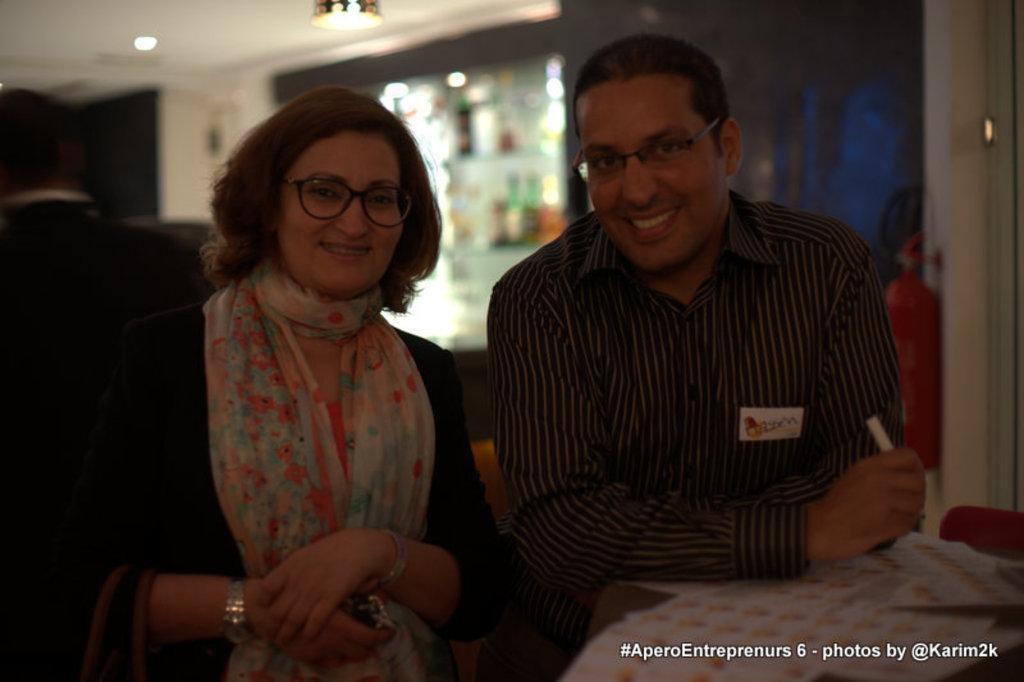Could you give a brief overview of what you see in this image? In this image in the foreground there is one man and one woman who are wearing spectacles and smiling, and man is holding a pen and in front of him there are some papers. And on the right side of the image there is a cylinder, wall and some lights and in the background there is one person, wall, objects and at the top there is ceiling and in the bottom right hand corner there is text. 